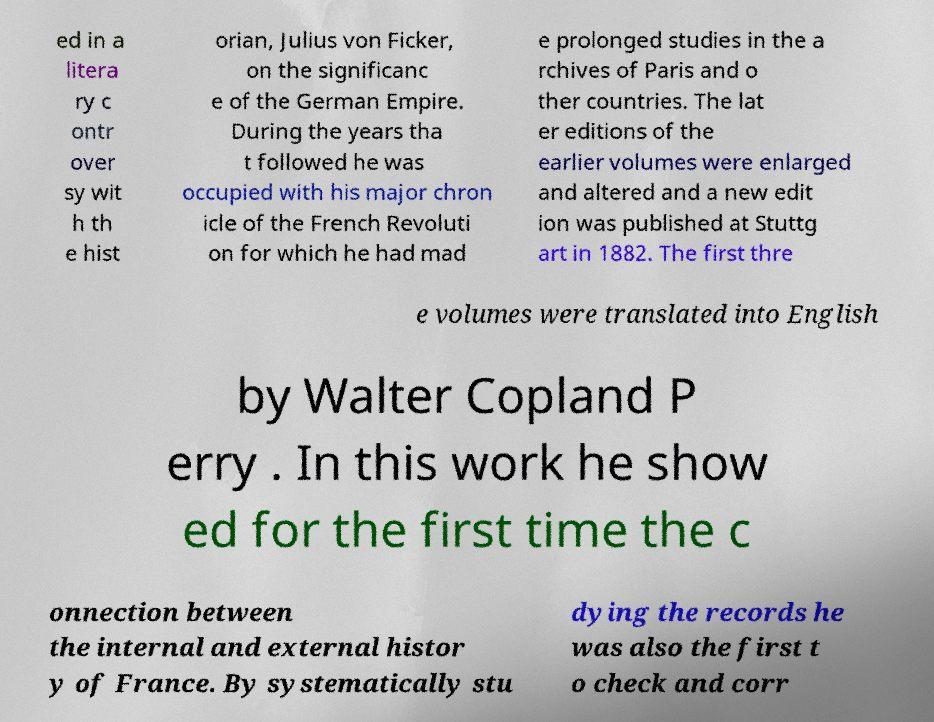Please identify and transcribe the text found in this image. ed in a litera ry c ontr over sy wit h th e hist orian, Julius von Ficker, on the significanc e of the German Empire. During the years tha t followed he was occupied with his major chron icle of the French Revoluti on for which he had mad e prolonged studies in the a rchives of Paris and o ther countries. The lat er editions of the earlier volumes were enlarged and altered and a new edit ion was published at Stuttg art in 1882. The first thre e volumes were translated into English by Walter Copland P erry . In this work he show ed for the first time the c onnection between the internal and external histor y of France. By systematically stu dying the records he was also the first t o check and corr 